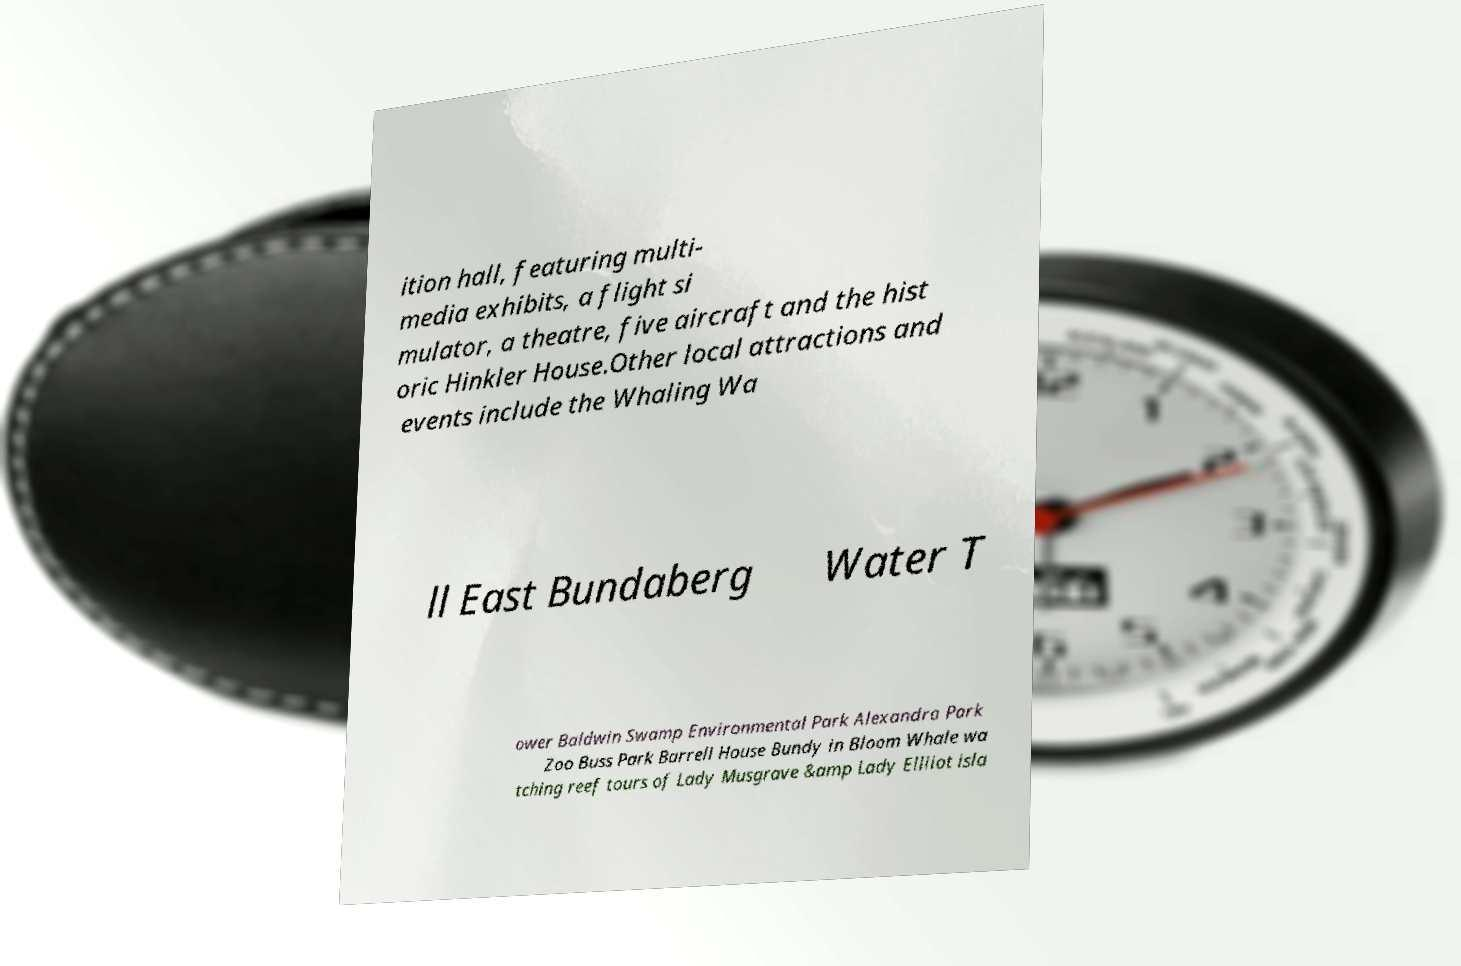Could you assist in decoding the text presented in this image and type it out clearly? ition hall, featuring multi- media exhibits, a flight si mulator, a theatre, five aircraft and the hist oric Hinkler House.Other local attractions and events include the Whaling Wa ll East Bundaberg Water T ower Baldwin Swamp Environmental Park Alexandra Park Zoo Buss Park Barrell House Bundy in Bloom Whale wa tching reef tours of Lady Musgrave &amp Lady Elliiot isla 